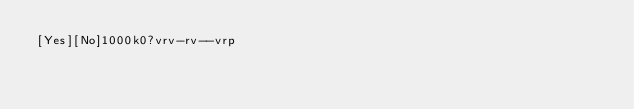<code> <loc_0><loc_0><loc_500><loc_500><_dc_>[Yes][No]1000k0?vrv-rv--vrp</code> 